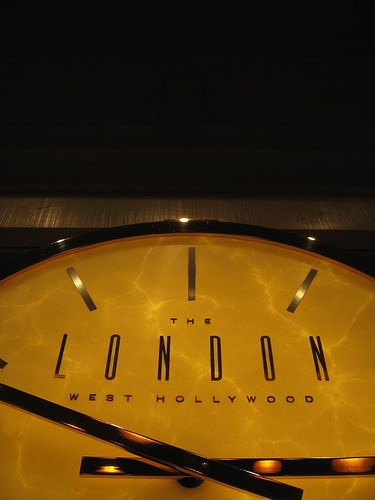Describe the objects in this image and their specific colors. I can see a clock in black, olive, orange, and maroon tones in this image. 